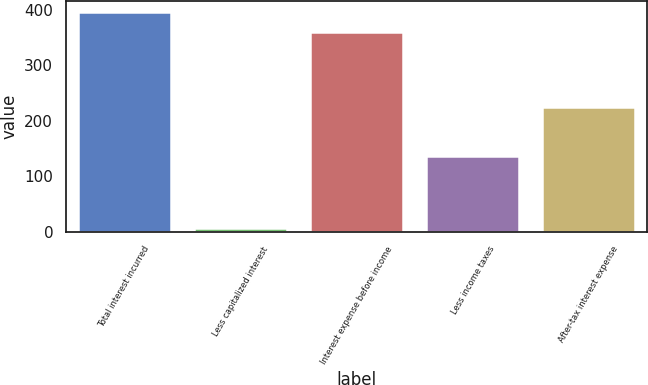<chart> <loc_0><loc_0><loc_500><loc_500><bar_chart><fcel>Total interest incurred<fcel>Less capitalized interest<fcel>Interest expense before income<fcel>Less income taxes<fcel>After-tax interest expense<nl><fcel>396<fcel>6<fcel>360<fcel>136<fcel>224<nl></chart> 